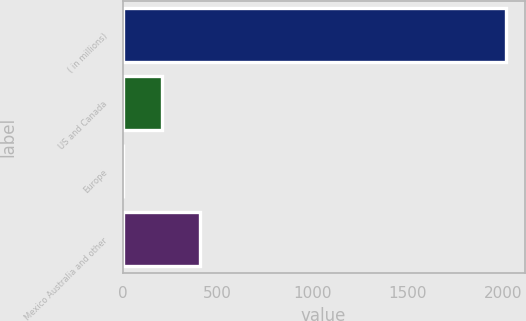Convert chart. <chart><loc_0><loc_0><loc_500><loc_500><bar_chart><fcel>( in millions)<fcel>US and Canada<fcel>Europe<fcel>Mexico Australia and other<nl><fcel>2015<fcel>205.01<fcel>3.9<fcel>406.12<nl></chart> 